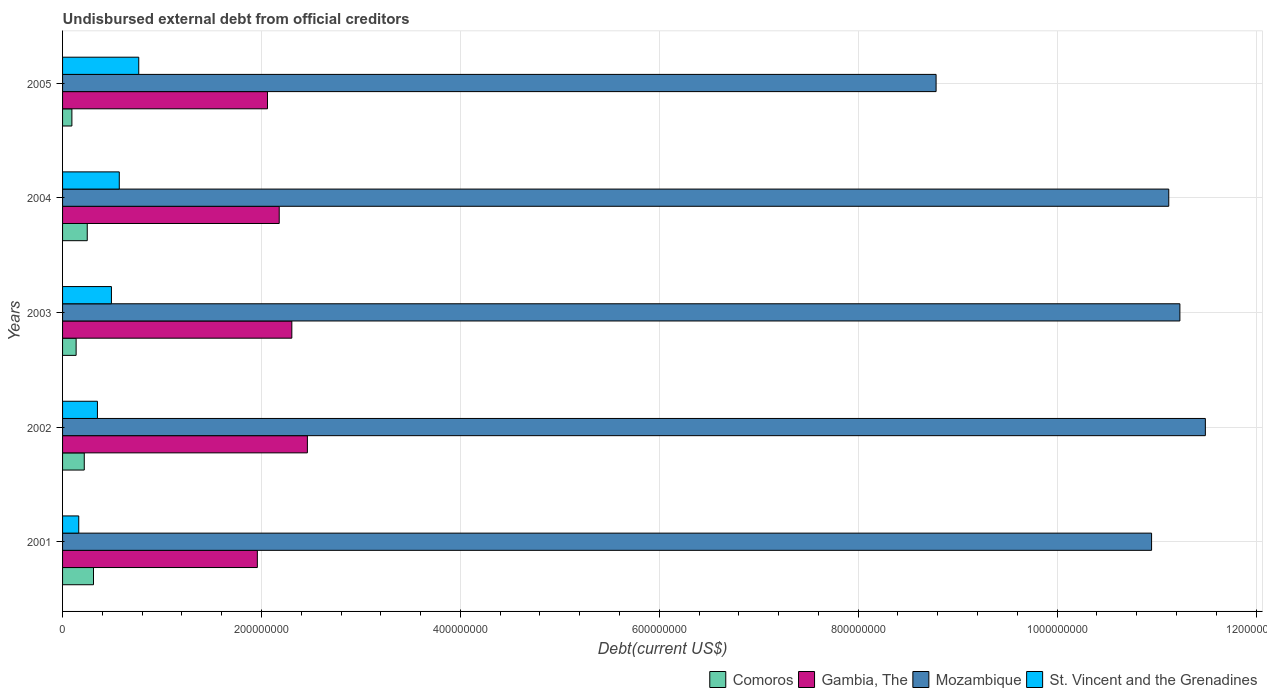How many groups of bars are there?
Provide a succinct answer. 5. Are the number of bars on each tick of the Y-axis equal?
Your answer should be very brief. Yes. How many bars are there on the 4th tick from the top?
Your response must be concise. 4. What is the total debt in Comoros in 2002?
Keep it short and to the point. 2.18e+07. Across all years, what is the maximum total debt in Comoros?
Give a very brief answer. 3.11e+07. Across all years, what is the minimum total debt in Comoros?
Provide a succinct answer. 9.37e+06. In which year was the total debt in Comoros maximum?
Ensure brevity in your answer.  2001. In which year was the total debt in Mozambique minimum?
Make the answer very short. 2005. What is the total total debt in Gambia, The in the graph?
Offer a very short reply. 1.10e+09. What is the difference between the total debt in Comoros in 2002 and that in 2005?
Your answer should be very brief. 1.24e+07. What is the difference between the total debt in St. Vincent and the Grenadines in 2001 and the total debt in Comoros in 2002?
Provide a short and direct response. -5.54e+06. What is the average total debt in Comoros per year?
Your answer should be compact. 2.02e+07. In the year 2005, what is the difference between the total debt in St. Vincent and the Grenadines and total debt in Mozambique?
Your answer should be compact. -8.02e+08. In how many years, is the total debt in Mozambique greater than 720000000 US$?
Offer a terse response. 5. What is the ratio of the total debt in Comoros in 2001 to that in 2004?
Your response must be concise. 1.25. Is the total debt in Comoros in 2003 less than that in 2004?
Provide a succinct answer. Yes. Is the difference between the total debt in St. Vincent and the Grenadines in 2002 and 2004 greater than the difference between the total debt in Mozambique in 2002 and 2004?
Your answer should be compact. No. What is the difference between the highest and the second highest total debt in Mozambique?
Give a very brief answer. 2.56e+07. What is the difference between the highest and the lowest total debt in Gambia, The?
Ensure brevity in your answer.  5.03e+07. Is it the case that in every year, the sum of the total debt in St. Vincent and the Grenadines and total debt in Gambia, The is greater than the sum of total debt in Comoros and total debt in Mozambique?
Provide a succinct answer. No. What does the 3rd bar from the top in 2002 represents?
Give a very brief answer. Gambia, The. What does the 2nd bar from the bottom in 2005 represents?
Your response must be concise. Gambia, The. How many bars are there?
Provide a short and direct response. 20. Are all the bars in the graph horizontal?
Your answer should be very brief. Yes. How many years are there in the graph?
Offer a very short reply. 5. Where does the legend appear in the graph?
Offer a terse response. Bottom right. What is the title of the graph?
Provide a short and direct response. Undisbursed external debt from official creditors. What is the label or title of the X-axis?
Ensure brevity in your answer.  Debt(current US$). What is the label or title of the Y-axis?
Provide a short and direct response. Years. What is the Debt(current US$) of Comoros in 2001?
Make the answer very short. 3.11e+07. What is the Debt(current US$) in Gambia, The in 2001?
Provide a succinct answer. 1.96e+08. What is the Debt(current US$) in Mozambique in 2001?
Ensure brevity in your answer.  1.09e+09. What is the Debt(current US$) of St. Vincent and the Grenadines in 2001?
Offer a very short reply. 1.63e+07. What is the Debt(current US$) in Comoros in 2002?
Make the answer very short. 2.18e+07. What is the Debt(current US$) of Gambia, The in 2002?
Keep it short and to the point. 2.46e+08. What is the Debt(current US$) in Mozambique in 2002?
Your answer should be very brief. 1.15e+09. What is the Debt(current US$) in St. Vincent and the Grenadines in 2002?
Ensure brevity in your answer.  3.51e+07. What is the Debt(current US$) in Comoros in 2003?
Offer a very short reply. 1.36e+07. What is the Debt(current US$) of Gambia, The in 2003?
Make the answer very short. 2.31e+08. What is the Debt(current US$) of Mozambique in 2003?
Keep it short and to the point. 1.12e+09. What is the Debt(current US$) of St. Vincent and the Grenadines in 2003?
Keep it short and to the point. 4.91e+07. What is the Debt(current US$) of Comoros in 2004?
Offer a terse response. 2.48e+07. What is the Debt(current US$) of Gambia, The in 2004?
Give a very brief answer. 2.18e+08. What is the Debt(current US$) of Mozambique in 2004?
Your response must be concise. 1.11e+09. What is the Debt(current US$) in St. Vincent and the Grenadines in 2004?
Offer a very short reply. 5.70e+07. What is the Debt(current US$) in Comoros in 2005?
Ensure brevity in your answer.  9.37e+06. What is the Debt(current US$) in Gambia, The in 2005?
Provide a short and direct response. 2.06e+08. What is the Debt(current US$) of Mozambique in 2005?
Make the answer very short. 8.78e+08. What is the Debt(current US$) of St. Vincent and the Grenadines in 2005?
Offer a very short reply. 7.66e+07. Across all years, what is the maximum Debt(current US$) in Comoros?
Give a very brief answer. 3.11e+07. Across all years, what is the maximum Debt(current US$) in Gambia, The?
Keep it short and to the point. 2.46e+08. Across all years, what is the maximum Debt(current US$) of Mozambique?
Offer a very short reply. 1.15e+09. Across all years, what is the maximum Debt(current US$) in St. Vincent and the Grenadines?
Ensure brevity in your answer.  7.66e+07. Across all years, what is the minimum Debt(current US$) in Comoros?
Your answer should be compact. 9.37e+06. Across all years, what is the minimum Debt(current US$) of Gambia, The?
Offer a very short reply. 1.96e+08. Across all years, what is the minimum Debt(current US$) in Mozambique?
Ensure brevity in your answer.  8.78e+08. Across all years, what is the minimum Debt(current US$) in St. Vincent and the Grenadines?
Ensure brevity in your answer.  1.63e+07. What is the total Debt(current US$) in Comoros in the graph?
Offer a terse response. 1.01e+08. What is the total Debt(current US$) of Gambia, The in the graph?
Provide a succinct answer. 1.10e+09. What is the total Debt(current US$) of Mozambique in the graph?
Provide a short and direct response. 5.36e+09. What is the total Debt(current US$) in St. Vincent and the Grenadines in the graph?
Ensure brevity in your answer.  2.34e+08. What is the difference between the Debt(current US$) of Comoros in 2001 and that in 2002?
Ensure brevity in your answer.  9.30e+06. What is the difference between the Debt(current US$) in Gambia, The in 2001 and that in 2002?
Offer a terse response. -5.03e+07. What is the difference between the Debt(current US$) of Mozambique in 2001 and that in 2002?
Ensure brevity in your answer.  -5.41e+07. What is the difference between the Debt(current US$) in St. Vincent and the Grenadines in 2001 and that in 2002?
Keep it short and to the point. -1.88e+07. What is the difference between the Debt(current US$) in Comoros in 2001 and that in 2003?
Keep it short and to the point. 1.75e+07. What is the difference between the Debt(current US$) in Gambia, The in 2001 and that in 2003?
Offer a terse response. -3.47e+07. What is the difference between the Debt(current US$) of Mozambique in 2001 and that in 2003?
Provide a short and direct response. -2.85e+07. What is the difference between the Debt(current US$) in St. Vincent and the Grenadines in 2001 and that in 2003?
Provide a succinct answer. -3.29e+07. What is the difference between the Debt(current US$) in Comoros in 2001 and that in 2004?
Give a very brief answer. 6.28e+06. What is the difference between the Debt(current US$) of Gambia, The in 2001 and that in 2004?
Make the answer very short. -2.20e+07. What is the difference between the Debt(current US$) of Mozambique in 2001 and that in 2004?
Your answer should be compact. -1.73e+07. What is the difference between the Debt(current US$) in St. Vincent and the Grenadines in 2001 and that in 2004?
Ensure brevity in your answer.  -4.08e+07. What is the difference between the Debt(current US$) of Comoros in 2001 and that in 2005?
Your response must be concise. 2.17e+07. What is the difference between the Debt(current US$) in Gambia, The in 2001 and that in 2005?
Your answer should be compact. -1.02e+07. What is the difference between the Debt(current US$) in Mozambique in 2001 and that in 2005?
Ensure brevity in your answer.  2.17e+08. What is the difference between the Debt(current US$) in St. Vincent and the Grenadines in 2001 and that in 2005?
Your response must be concise. -6.03e+07. What is the difference between the Debt(current US$) in Comoros in 2002 and that in 2003?
Your response must be concise. 8.18e+06. What is the difference between the Debt(current US$) of Gambia, The in 2002 and that in 2003?
Offer a very short reply. 1.56e+07. What is the difference between the Debt(current US$) of Mozambique in 2002 and that in 2003?
Keep it short and to the point. 2.56e+07. What is the difference between the Debt(current US$) of St. Vincent and the Grenadines in 2002 and that in 2003?
Give a very brief answer. -1.41e+07. What is the difference between the Debt(current US$) in Comoros in 2002 and that in 2004?
Provide a short and direct response. -3.01e+06. What is the difference between the Debt(current US$) of Gambia, The in 2002 and that in 2004?
Offer a terse response. 2.83e+07. What is the difference between the Debt(current US$) of Mozambique in 2002 and that in 2004?
Give a very brief answer. 3.68e+07. What is the difference between the Debt(current US$) in St. Vincent and the Grenadines in 2002 and that in 2004?
Provide a short and direct response. -2.20e+07. What is the difference between the Debt(current US$) in Comoros in 2002 and that in 2005?
Provide a succinct answer. 1.24e+07. What is the difference between the Debt(current US$) of Gambia, The in 2002 and that in 2005?
Your answer should be compact. 4.01e+07. What is the difference between the Debt(current US$) in Mozambique in 2002 and that in 2005?
Ensure brevity in your answer.  2.71e+08. What is the difference between the Debt(current US$) in St. Vincent and the Grenadines in 2002 and that in 2005?
Make the answer very short. -4.15e+07. What is the difference between the Debt(current US$) of Comoros in 2003 and that in 2004?
Offer a terse response. -1.12e+07. What is the difference between the Debt(current US$) of Gambia, The in 2003 and that in 2004?
Your answer should be compact. 1.27e+07. What is the difference between the Debt(current US$) of Mozambique in 2003 and that in 2004?
Your response must be concise. 1.12e+07. What is the difference between the Debt(current US$) in St. Vincent and the Grenadines in 2003 and that in 2004?
Your answer should be compact. -7.89e+06. What is the difference between the Debt(current US$) in Comoros in 2003 and that in 2005?
Your answer should be very brief. 4.26e+06. What is the difference between the Debt(current US$) of Gambia, The in 2003 and that in 2005?
Ensure brevity in your answer.  2.45e+07. What is the difference between the Debt(current US$) in Mozambique in 2003 and that in 2005?
Offer a terse response. 2.45e+08. What is the difference between the Debt(current US$) in St. Vincent and the Grenadines in 2003 and that in 2005?
Your response must be concise. -2.75e+07. What is the difference between the Debt(current US$) in Comoros in 2004 and that in 2005?
Ensure brevity in your answer.  1.55e+07. What is the difference between the Debt(current US$) in Gambia, The in 2004 and that in 2005?
Offer a terse response. 1.18e+07. What is the difference between the Debt(current US$) of Mozambique in 2004 and that in 2005?
Provide a short and direct response. 2.34e+08. What is the difference between the Debt(current US$) of St. Vincent and the Grenadines in 2004 and that in 2005?
Offer a terse response. -1.96e+07. What is the difference between the Debt(current US$) in Comoros in 2001 and the Debt(current US$) in Gambia, The in 2002?
Offer a terse response. -2.15e+08. What is the difference between the Debt(current US$) of Comoros in 2001 and the Debt(current US$) of Mozambique in 2002?
Ensure brevity in your answer.  -1.12e+09. What is the difference between the Debt(current US$) of Comoros in 2001 and the Debt(current US$) of St. Vincent and the Grenadines in 2002?
Offer a very short reply. -3.95e+06. What is the difference between the Debt(current US$) in Gambia, The in 2001 and the Debt(current US$) in Mozambique in 2002?
Ensure brevity in your answer.  -9.53e+08. What is the difference between the Debt(current US$) of Gambia, The in 2001 and the Debt(current US$) of St. Vincent and the Grenadines in 2002?
Provide a succinct answer. 1.61e+08. What is the difference between the Debt(current US$) in Mozambique in 2001 and the Debt(current US$) in St. Vincent and the Grenadines in 2002?
Your response must be concise. 1.06e+09. What is the difference between the Debt(current US$) in Comoros in 2001 and the Debt(current US$) in Gambia, The in 2003?
Your answer should be compact. -1.99e+08. What is the difference between the Debt(current US$) of Comoros in 2001 and the Debt(current US$) of Mozambique in 2003?
Provide a short and direct response. -1.09e+09. What is the difference between the Debt(current US$) of Comoros in 2001 and the Debt(current US$) of St. Vincent and the Grenadines in 2003?
Your answer should be compact. -1.80e+07. What is the difference between the Debt(current US$) in Gambia, The in 2001 and the Debt(current US$) in Mozambique in 2003?
Provide a short and direct response. -9.28e+08. What is the difference between the Debt(current US$) of Gambia, The in 2001 and the Debt(current US$) of St. Vincent and the Grenadines in 2003?
Provide a succinct answer. 1.47e+08. What is the difference between the Debt(current US$) of Mozambique in 2001 and the Debt(current US$) of St. Vincent and the Grenadines in 2003?
Provide a succinct answer. 1.05e+09. What is the difference between the Debt(current US$) in Comoros in 2001 and the Debt(current US$) in Gambia, The in 2004?
Offer a very short reply. -1.87e+08. What is the difference between the Debt(current US$) of Comoros in 2001 and the Debt(current US$) of Mozambique in 2004?
Keep it short and to the point. -1.08e+09. What is the difference between the Debt(current US$) in Comoros in 2001 and the Debt(current US$) in St. Vincent and the Grenadines in 2004?
Offer a terse response. -2.59e+07. What is the difference between the Debt(current US$) of Gambia, The in 2001 and the Debt(current US$) of Mozambique in 2004?
Give a very brief answer. -9.16e+08. What is the difference between the Debt(current US$) in Gambia, The in 2001 and the Debt(current US$) in St. Vincent and the Grenadines in 2004?
Make the answer very short. 1.39e+08. What is the difference between the Debt(current US$) of Mozambique in 2001 and the Debt(current US$) of St. Vincent and the Grenadines in 2004?
Make the answer very short. 1.04e+09. What is the difference between the Debt(current US$) of Comoros in 2001 and the Debt(current US$) of Gambia, The in 2005?
Your answer should be compact. -1.75e+08. What is the difference between the Debt(current US$) of Comoros in 2001 and the Debt(current US$) of Mozambique in 2005?
Your response must be concise. -8.47e+08. What is the difference between the Debt(current US$) in Comoros in 2001 and the Debt(current US$) in St. Vincent and the Grenadines in 2005?
Keep it short and to the point. -4.55e+07. What is the difference between the Debt(current US$) in Gambia, The in 2001 and the Debt(current US$) in Mozambique in 2005?
Ensure brevity in your answer.  -6.82e+08. What is the difference between the Debt(current US$) of Gambia, The in 2001 and the Debt(current US$) of St. Vincent and the Grenadines in 2005?
Your answer should be very brief. 1.19e+08. What is the difference between the Debt(current US$) of Mozambique in 2001 and the Debt(current US$) of St. Vincent and the Grenadines in 2005?
Make the answer very short. 1.02e+09. What is the difference between the Debt(current US$) in Comoros in 2002 and the Debt(current US$) in Gambia, The in 2003?
Offer a very short reply. -2.09e+08. What is the difference between the Debt(current US$) in Comoros in 2002 and the Debt(current US$) in Mozambique in 2003?
Provide a succinct answer. -1.10e+09. What is the difference between the Debt(current US$) in Comoros in 2002 and the Debt(current US$) in St. Vincent and the Grenadines in 2003?
Provide a succinct answer. -2.73e+07. What is the difference between the Debt(current US$) in Gambia, The in 2002 and the Debt(current US$) in Mozambique in 2003?
Offer a terse response. -8.77e+08. What is the difference between the Debt(current US$) of Gambia, The in 2002 and the Debt(current US$) of St. Vincent and the Grenadines in 2003?
Ensure brevity in your answer.  1.97e+08. What is the difference between the Debt(current US$) of Mozambique in 2002 and the Debt(current US$) of St. Vincent and the Grenadines in 2003?
Give a very brief answer. 1.10e+09. What is the difference between the Debt(current US$) in Comoros in 2002 and the Debt(current US$) in Gambia, The in 2004?
Make the answer very short. -1.96e+08. What is the difference between the Debt(current US$) of Comoros in 2002 and the Debt(current US$) of Mozambique in 2004?
Your answer should be very brief. -1.09e+09. What is the difference between the Debt(current US$) in Comoros in 2002 and the Debt(current US$) in St. Vincent and the Grenadines in 2004?
Offer a very short reply. -3.52e+07. What is the difference between the Debt(current US$) of Gambia, The in 2002 and the Debt(current US$) of Mozambique in 2004?
Your answer should be very brief. -8.66e+08. What is the difference between the Debt(current US$) in Gambia, The in 2002 and the Debt(current US$) in St. Vincent and the Grenadines in 2004?
Keep it short and to the point. 1.89e+08. What is the difference between the Debt(current US$) of Mozambique in 2002 and the Debt(current US$) of St. Vincent and the Grenadines in 2004?
Offer a terse response. 1.09e+09. What is the difference between the Debt(current US$) of Comoros in 2002 and the Debt(current US$) of Gambia, The in 2005?
Make the answer very short. -1.84e+08. What is the difference between the Debt(current US$) of Comoros in 2002 and the Debt(current US$) of Mozambique in 2005?
Keep it short and to the point. -8.57e+08. What is the difference between the Debt(current US$) of Comoros in 2002 and the Debt(current US$) of St. Vincent and the Grenadines in 2005?
Keep it short and to the point. -5.48e+07. What is the difference between the Debt(current US$) of Gambia, The in 2002 and the Debt(current US$) of Mozambique in 2005?
Your answer should be compact. -6.32e+08. What is the difference between the Debt(current US$) of Gambia, The in 2002 and the Debt(current US$) of St. Vincent and the Grenadines in 2005?
Make the answer very short. 1.70e+08. What is the difference between the Debt(current US$) of Mozambique in 2002 and the Debt(current US$) of St. Vincent and the Grenadines in 2005?
Ensure brevity in your answer.  1.07e+09. What is the difference between the Debt(current US$) in Comoros in 2003 and the Debt(current US$) in Gambia, The in 2004?
Your response must be concise. -2.04e+08. What is the difference between the Debt(current US$) in Comoros in 2003 and the Debt(current US$) in Mozambique in 2004?
Keep it short and to the point. -1.10e+09. What is the difference between the Debt(current US$) in Comoros in 2003 and the Debt(current US$) in St. Vincent and the Grenadines in 2004?
Keep it short and to the point. -4.34e+07. What is the difference between the Debt(current US$) in Gambia, The in 2003 and the Debt(current US$) in Mozambique in 2004?
Keep it short and to the point. -8.82e+08. What is the difference between the Debt(current US$) in Gambia, The in 2003 and the Debt(current US$) in St. Vincent and the Grenadines in 2004?
Make the answer very short. 1.73e+08. What is the difference between the Debt(current US$) in Mozambique in 2003 and the Debt(current US$) in St. Vincent and the Grenadines in 2004?
Provide a short and direct response. 1.07e+09. What is the difference between the Debt(current US$) of Comoros in 2003 and the Debt(current US$) of Gambia, The in 2005?
Your answer should be compact. -1.92e+08. What is the difference between the Debt(current US$) in Comoros in 2003 and the Debt(current US$) in Mozambique in 2005?
Your answer should be compact. -8.65e+08. What is the difference between the Debt(current US$) in Comoros in 2003 and the Debt(current US$) in St. Vincent and the Grenadines in 2005?
Make the answer very short. -6.30e+07. What is the difference between the Debt(current US$) in Gambia, The in 2003 and the Debt(current US$) in Mozambique in 2005?
Provide a succinct answer. -6.48e+08. What is the difference between the Debt(current US$) of Gambia, The in 2003 and the Debt(current US$) of St. Vincent and the Grenadines in 2005?
Your response must be concise. 1.54e+08. What is the difference between the Debt(current US$) in Mozambique in 2003 and the Debt(current US$) in St. Vincent and the Grenadines in 2005?
Make the answer very short. 1.05e+09. What is the difference between the Debt(current US$) of Comoros in 2004 and the Debt(current US$) of Gambia, The in 2005?
Your response must be concise. -1.81e+08. What is the difference between the Debt(current US$) of Comoros in 2004 and the Debt(current US$) of Mozambique in 2005?
Your answer should be very brief. -8.54e+08. What is the difference between the Debt(current US$) of Comoros in 2004 and the Debt(current US$) of St. Vincent and the Grenadines in 2005?
Give a very brief answer. -5.18e+07. What is the difference between the Debt(current US$) in Gambia, The in 2004 and the Debt(current US$) in Mozambique in 2005?
Your response must be concise. -6.60e+08. What is the difference between the Debt(current US$) in Gambia, The in 2004 and the Debt(current US$) in St. Vincent and the Grenadines in 2005?
Make the answer very short. 1.41e+08. What is the difference between the Debt(current US$) of Mozambique in 2004 and the Debt(current US$) of St. Vincent and the Grenadines in 2005?
Offer a terse response. 1.04e+09. What is the average Debt(current US$) of Comoros per year?
Provide a short and direct response. 2.02e+07. What is the average Debt(current US$) of Gambia, The per year?
Ensure brevity in your answer.  2.19e+08. What is the average Debt(current US$) in Mozambique per year?
Provide a short and direct response. 1.07e+09. What is the average Debt(current US$) of St. Vincent and the Grenadines per year?
Your response must be concise. 4.68e+07. In the year 2001, what is the difference between the Debt(current US$) of Comoros and Debt(current US$) of Gambia, The?
Give a very brief answer. -1.65e+08. In the year 2001, what is the difference between the Debt(current US$) of Comoros and Debt(current US$) of Mozambique?
Ensure brevity in your answer.  -1.06e+09. In the year 2001, what is the difference between the Debt(current US$) in Comoros and Debt(current US$) in St. Vincent and the Grenadines?
Your response must be concise. 1.48e+07. In the year 2001, what is the difference between the Debt(current US$) of Gambia, The and Debt(current US$) of Mozambique?
Your answer should be compact. -8.99e+08. In the year 2001, what is the difference between the Debt(current US$) of Gambia, The and Debt(current US$) of St. Vincent and the Grenadines?
Provide a succinct answer. 1.80e+08. In the year 2001, what is the difference between the Debt(current US$) of Mozambique and Debt(current US$) of St. Vincent and the Grenadines?
Make the answer very short. 1.08e+09. In the year 2002, what is the difference between the Debt(current US$) in Comoros and Debt(current US$) in Gambia, The?
Your answer should be compact. -2.24e+08. In the year 2002, what is the difference between the Debt(current US$) in Comoros and Debt(current US$) in Mozambique?
Provide a succinct answer. -1.13e+09. In the year 2002, what is the difference between the Debt(current US$) of Comoros and Debt(current US$) of St. Vincent and the Grenadines?
Make the answer very short. -1.32e+07. In the year 2002, what is the difference between the Debt(current US$) of Gambia, The and Debt(current US$) of Mozambique?
Your answer should be very brief. -9.03e+08. In the year 2002, what is the difference between the Debt(current US$) in Gambia, The and Debt(current US$) in St. Vincent and the Grenadines?
Your answer should be compact. 2.11e+08. In the year 2002, what is the difference between the Debt(current US$) in Mozambique and Debt(current US$) in St. Vincent and the Grenadines?
Your answer should be very brief. 1.11e+09. In the year 2003, what is the difference between the Debt(current US$) in Comoros and Debt(current US$) in Gambia, The?
Provide a short and direct response. -2.17e+08. In the year 2003, what is the difference between the Debt(current US$) of Comoros and Debt(current US$) of Mozambique?
Offer a terse response. -1.11e+09. In the year 2003, what is the difference between the Debt(current US$) of Comoros and Debt(current US$) of St. Vincent and the Grenadines?
Make the answer very short. -3.55e+07. In the year 2003, what is the difference between the Debt(current US$) in Gambia, The and Debt(current US$) in Mozambique?
Make the answer very short. -8.93e+08. In the year 2003, what is the difference between the Debt(current US$) of Gambia, The and Debt(current US$) of St. Vincent and the Grenadines?
Give a very brief answer. 1.81e+08. In the year 2003, what is the difference between the Debt(current US$) in Mozambique and Debt(current US$) in St. Vincent and the Grenadines?
Offer a terse response. 1.07e+09. In the year 2004, what is the difference between the Debt(current US$) of Comoros and Debt(current US$) of Gambia, The?
Ensure brevity in your answer.  -1.93e+08. In the year 2004, what is the difference between the Debt(current US$) in Comoros and Debt(current US$) in Mozambique?
Your answer should be compact. -1.09e+09. In the year 2004, what is the difference between the Debt(current US$) in Comoros and Debt(current US$) in St. Vincent and the Grenadines?
Provide a succinct answer. -3.22e+07. In the year 2004, what is the difference between the Debt(current US$) of Gambia, The and Debt(current US$) of Mozambique?
Make the answer very short. -8.94e+08. In the year 2004, what is the difference between the Debt(current US$) of Gambia, The and Debt(current US$) of St. Vincent and the Grenadines?
Make the answer very short. 1.61e+08. In the year 2004, what is the difference between the Debt(current US$) in Mozambique and Debt(current US$) in St. Vincent and the Grenadines?
Your answer should be very brief. 1.06e+09. In the year 2005, what is the difference between the Debt(current US$) in Comoros and Debt(current US$) in Gambia, The?
Offer a very short reply. -1.97e+08. In the year 2005, what is the difference between the Debt(current US$) of Comoros and Debt(current US$) of Mozambique?
Offer a terse response. -8.69e+08. In the year 2005, what is the difference between the Debt(current US$) in Comoros and Debt(current US$) in St. Vincent and the Grenadines?
Ensure brevity in your answer.  -6.72e+07. In the year 2005, what is the difference between the Debt(current US$) in Gambia, The and Debt(current US$) in Mozambique?
Provide a succinct answer. -6.72e+08. In the year 2005, what is the difference between the Debt(current US$) of Gambia, The and Debt(current US$) of St. Vincent and the Grenadines?
Your response must be concise. 1.29e+08. In the year 2005, what is the difference between the Debt(current US$) in Mozambique and Debt(current US$) in St. Vincent and the Grenadines?
Make the answer very short. 8.02e+08. What is the ratio of the Debt(current US$) in Comoros in 2001 to that in 2002?
Ensure brevity in your answer.  1.43. What is the ratio of the Debt(current US$) in Gambia, The in 2001 to that in 2002?
Ensure brevity in your answer.  0.8. What is the ratio of the Debt(current US$) of Mozambique in 2001 to that in 2002?
Give a very brief answer. 0.95. What is the ratio of the Debt(current US$) of St. Vincent and the Grenadines in 2001 to that in 2002?
Offer a terse response. 0.46. What is the ratio of the Debt(current US$) of Comoros in 2001 to that in 2003?
Your answer should be compact. 2.28. What is the ratio of the Debt(current US$) of Gambia, The in 2001 to that in 2003?
Keep it short and to the point. 0.85. What is the ratio of the Debt(current US$) in Mozambique in 2001 to that in 2003?
Your response must be concise. 0.97. What is the ratio of the Debt(current US$) of St. Vincent and the Grenadines in 2001 to that in 2003?
Provide a succinct answer. 0.33. What is the ratio of the Debt(current US$) of Comoros in 2001 to that in 2004?
Provide a succinct answer. 1.25. What is the ratio of the Debt(current US$) in Gambia, The in 2001 to that in 2004?
Offer a terse response. 0.9. What is the ratio of the Debt(current US$) in Mozambique in 2001 to that in 2004?
Your answer should be very brief. 0.98. What is the ratio of the Debt(current US$) in St. Vincent and the Grenadines in 2001 to that in 2004?
Offer a terse response. 0.29. What is the ratio of the Debt(current US$) in Comoros in 2001 to that in 2005?
Provide a short and direct response. 3.32. What is the ratio of the Debt(current US$) in Gambia, The in 2001 to that in 2005?
Your answer should be compact. 0.95. What is the ratio of the Debt(current US$) of Mozambique in 2001 to that in 2005?
Your response must be concise. 1.25. What is the ratio of the Debt(current US$) in St. Vincent and the Grenadines in 2001 to that in 2005?
Ensure brevity in your answer.  0.21. What is the ratio of the Debt(current US$) of Comoros in 2002 to that in 2003?
Make the answer very short. 1.6. What is the ratio of the Debt(current US$) in Gambia, The in 2002 to that in 2003?
Keep it short and to the point. 1.07. What is the ratio of the Debt(current US$) in Mozambique in 2002 to that in 2003?
Ensure brevity in your answer.  1.02. What is the ratio of the Debt(current US$) in St. Vincent and the Grenadines in 2002 to that in 2003?
Your answer should be compact. 0.71. What is the ratio of the Debt(current US$) in Comoros in 2002 to that in 2004?
Your answer should be compact. 0.88. What is the ratio of the Debt(current US$) of Gambia, The in 2002 to that in 2004?
Provide a short and direct response. 1.13. What is the ratio of the Debt(current US$) in Mozambique in 2002 to that in 2004?
Make the answer very short. 1.03. What is the ratio of the Debt(current US$) of St. Vincent and the Grenadines in 2002 to that in 2004?
Keep it short and to the point. 0.61. What is the ratio of the Debt(current US$) in Comoros in 2002 to that in 2005?
Keep it short and to the point. 2.33. What is the ratio of the Debt(current US$) in Gambia, The in 2002 to that in 2005?
Your response must be concise. 1.19. What is the ratio of the Debt(current US$) in Mozambique in 2002 to that in 2005?
Provide a succinct answer. 1.31. What is the ratio of the Debt(current US$) of St. Vincent and the Grenadines in 2002 to that in 2005?
Make the answer very short. 0.46. What is the ratio of the Debt(current US$) of Comoros in 2003 to that in 2004?
Give a very brief answer. 0.55. What is the ratio of the Debt(current US$) of Gambia, The in 2003 to that in 2004?
Your response must be concise. 1.06. What is the ratio of the Debt(current US$) of St. Vincent and the Grenadines in 2003 to that in 2004?
Keep it short and to the point. 0.86. What is the ratio of the Debt(current US$) of Comoros in 2003 to that in 2005?
Your answer should be very brief. 1.45. What is the ratio of the Debt(current US$) in Gambia, The in 2003 to that in 2005?
Your response must be concise. 1.12. What is the ratio of the Debt(current US$) in Mozambique in 2003 to that in 2005?
Provide a succinct answer. 1.28. What is the ratio of the Debt(current US$) of St. Vincent and the Grenadines in 2003 to that in 2005?
Make the answer very short. 0.64. What is the ratio of the Debt(current US$) in Comoros in 2004 to that in 2005?
Give a very brief answer. 2.65. What is the ratio of the Debt(current US$) of Gambia, The in 2004 to that in 2005?
Your answer should be very brief. 1.06. What is the ratio of the Debt(current US$) in Mozambique in 2004 to that in 2005?
Provide a succinct answer. 1.27. What is the ratio of the Debt(current US$) in St. Vincent and the Grenadines in 2004 to that in 2005?
Provide a short and direct response. 0.74. What is the difference between the highest and the second highest Debt(current US$) of Comoros?
Provide a succinct answer. 6.28e+06. What is the difference between the highest and the second highest Debt(current US$) of Gambia, The?
Your answer should be compact. 1.56e+07. What is the difference between the highest and the second highest Debt(current US$) of Mozambique?
Keep it short and to the point. 2.56e+07. What is the difference between the highest and the second highest Debt(current US$) of St. Vincent and the Grenadines?
Offer a terse response. 1.96e+07. What is the difference between the highest and the lowest Debt(current US$) of Comoros?
Your answer should be compact. 2.17e+07. What is the difference between the highest and the lowest Debt(current US$) in Gambia, The?
Make the answer very short. 5.03e+07. What is the difference between the highest and the lowest Debt(current US$) in Mozambique?
Offer a terse response. 2.71e+08. What is the difference between the highest and the lowest Debt(current US$) in St. Vincent and the Grenadines?
Offer a very short reply. 6.03e+07. 